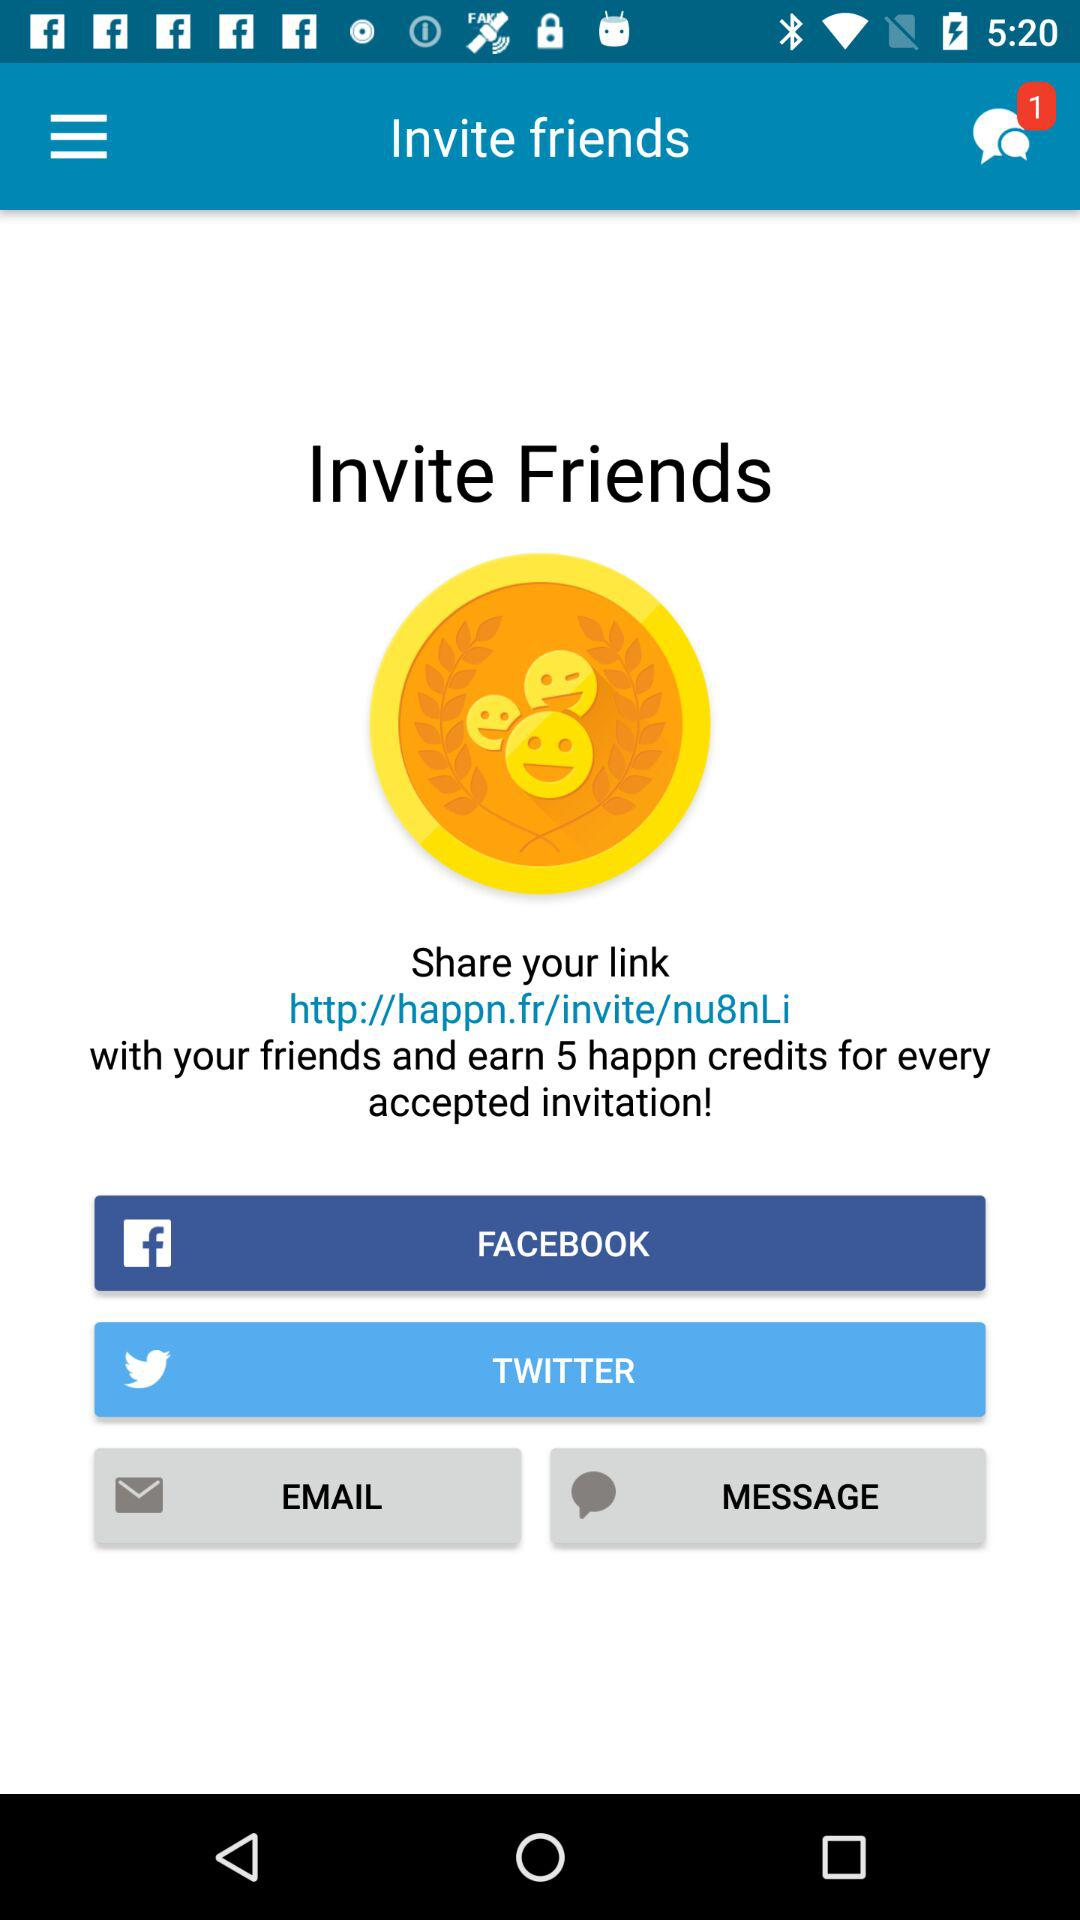How many credits do you earn for every accepted invitation?
Answer the question using a single word or phrase. 5 